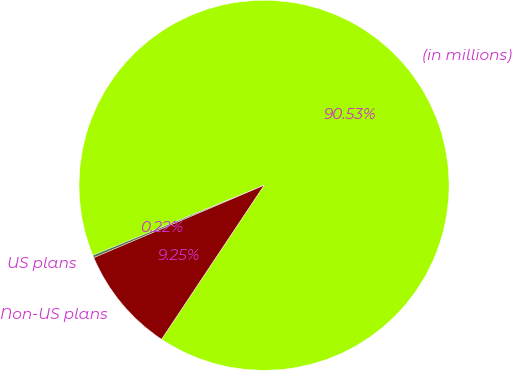Convert chart. <chart><loc_0><loc_0><loc_500><loc_500><pie_chart><fcel>(in millions)<fcel>US plans<fcel>Non-US plans<nl><fcel>90.52%<fcel>0.22%<fcel>9.25%<nl></chart> 